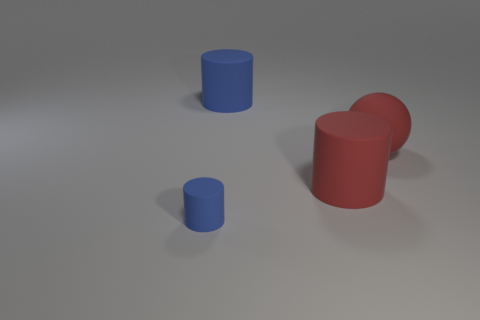The rubber thing that is the same color as the ball is what shape?
Offer a terse response. Cylinder. Are there an equal number of red objects in front of the small matte thing and red things that are to the left of the big matte sphere?
Your answer should be very brief. No. What number of things are tiny blocks or blue matte cylinders that are behind the small thing?
Keep it short and to the point. 1. The blue cylinder that is the same material as the large blue thing is what size?
Provide a short and direct response. Small. Is the number of balls that are in front of the small matte thing greater than the number of small red matte cubes?
Offer a terse response. No. There is a object that is both on the left side of the red matte cylinder and in front of the large blue thing; what is its size?
Ensure brevity in your answer.  Small. What material is the other blue thing that is the same shape as the tiny blue rubber thing?
Your answer should be very brief. Rubber. There is a rubber thing behind the ball; does it have the same size as the matte sphere?
Ensure brevity in your answer.  Yes. What is the color of the object that is both behind the small blue object and in front of the sphere?
Your response must be concise. Red. How many small rubber objects are behind the blue rubber thing behind the tiny blue object?
Keep it short and to the point. 0. 